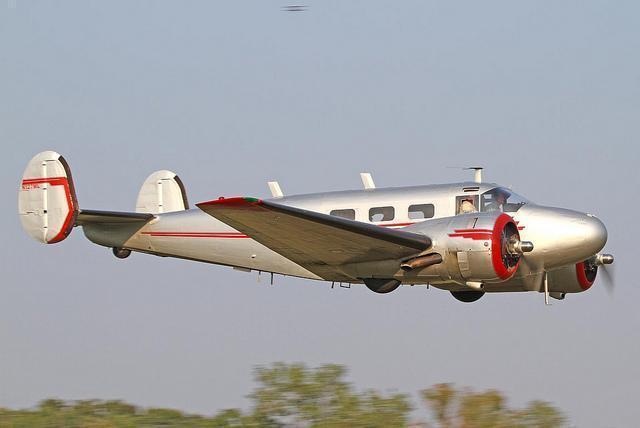What is seen in the sky?
Answer the question by selecting the correct answer among the 4 following choices and explain your choice with a short sentence. The answer should be formatted with the following format: `Answer: choice
Rationale: rationale.`
Options: Kite, airplane, bird, helicopter. Answer: airplane.
Rationale: This is obvious given the shape of the aircraft. 